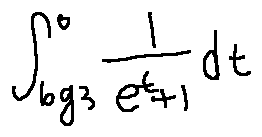<formula> <loc_0><loc_0><loc_500><loc_500>\int \lim i t s _ { \log 3 } ^ { 0 } \frac { 1 } { e ^ { t } + 1 } d t</formula> 